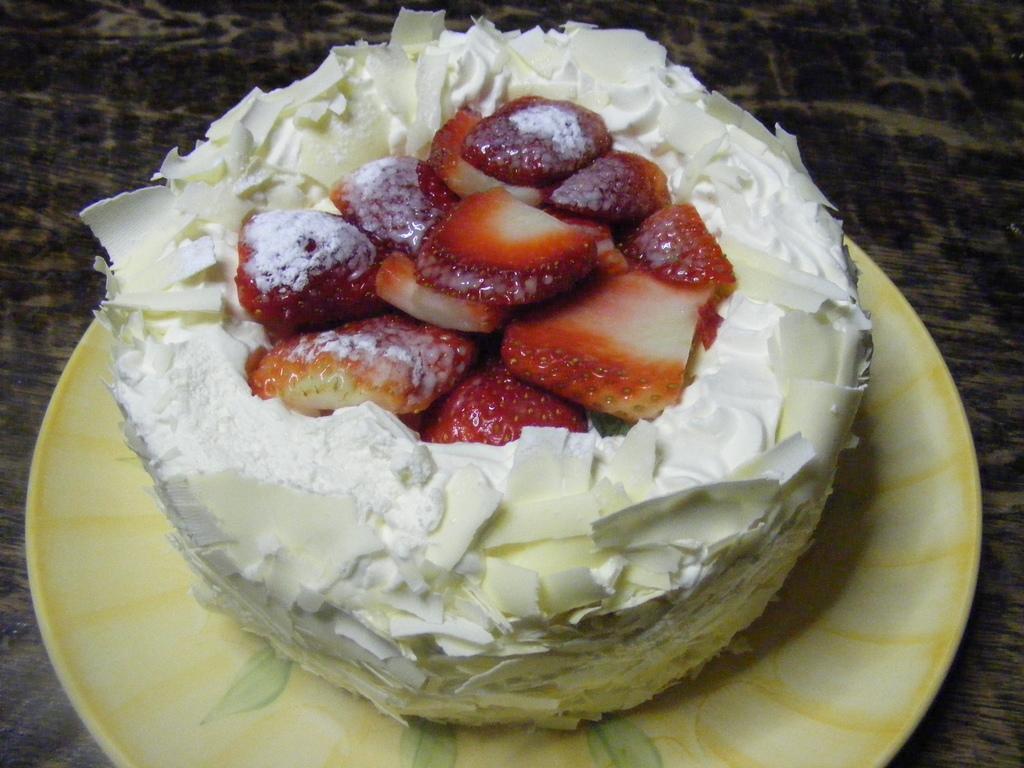How would you summarize this image in a sentence or two? In this picture we can see a cake in the plate and the plate is on the wooden surface. On top of the cake, there are strawberry slices. 